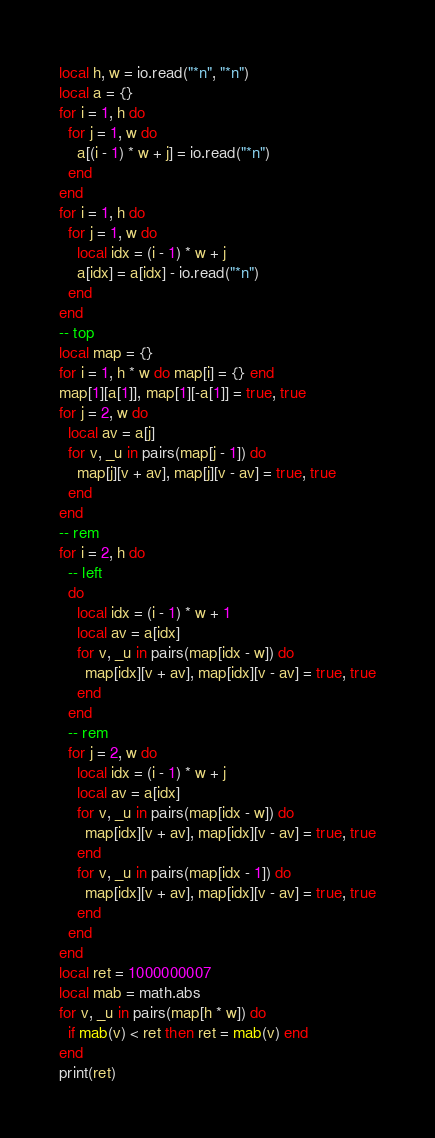Convert code to text. <code><loc_0><loc_0><loc_500><loc_500><_Lua_>local h, w = io.read("*n", "*n")
local a = {}
for i = 1, h do
  for j = 1, w do
    a[(i - 1) * w + j] = io.read("*n")
  end
end
for i = 1, h do
  for j = 1, w do
    local idx = (i - 1) * w + j
    a[idx] = a[idx] - io.read("*n")
  end
end
-- top
local map = {}
for i = 1, h * w do map[i] = {} end
map[1][a[1]], map[1][-a[1]] = true, true
for j = 2, w do
  local av = a[j]
  for v, _u in pairs(map[j - 1]) do
    map[j][v + av], map[j][v - av] = true, true
  end
end
-- rem
for i = 2, h do
  -- left
  do
    local idx = (i - 1) * w + 1
    local av = a[idx]
    for v, _u in pairs(map[idx - w]) do
      map[idx][v + av], map[idx][v - av] = true, true
    end
  end
  -- rem
  for j = 2, w do
    local idx = (i - 1) * w + j
    local av = a[idx]
    for v, _u in pairs(map[idx - w]) do
      map[idx][v + av], map[idx][v - av] = true, true
    end
    for v, _u in pairs(map[idx - 1]) do
      map[idx][v + av], map[idx][v - av] = true, true
    end
  end
end
local ret = 1000000007
local mab = math.abs
for v, _u in pairs(map[h * w]) do
  if mab(v) < ret then ret = mab(v) end
end
print(ret)
</code> 